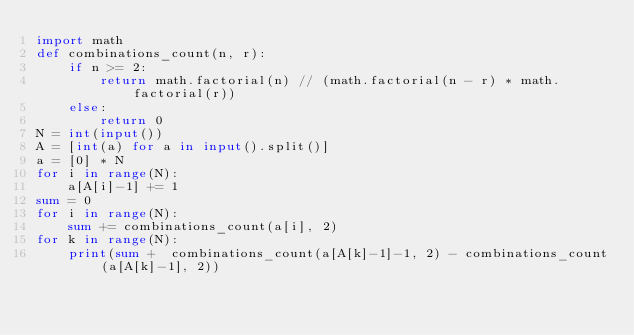<code> <loc_0><loc_0><loc_500><loc_500><_Python_>import math
def combinations_count(n, r):
    if n >= 2:
        return math.factorial(n) // (math.factorial(n - r) * math.factorial(r))
    else:
        return 0
N = int(input())
A = [int(a) for a in input().split()]
a = [0] * N
for i in range(N):
    a[A[i]-1] += 1
sum = 0
for i in range(N):
    sum += combinations_count(a[i], 2)
for k in range(N):
    print(sum +  combinations_count(a[A[k]-1]-1, 2) - combinations_count(a[A[k]-1], 2))
</code> 